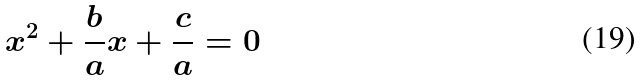Convert formula to latex. <formula><loc_0><loc_0><loc_500><loc_500>x ^ { 2 } + \frac { b } { a } x + \frac { c } { a } = 0</formula> 